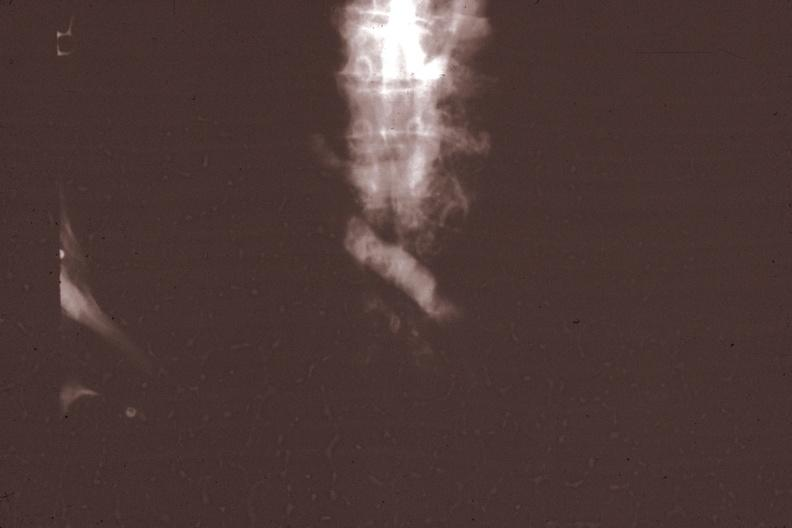what is present?
Answer the question using a single word or phrase. Malignant thymoma 